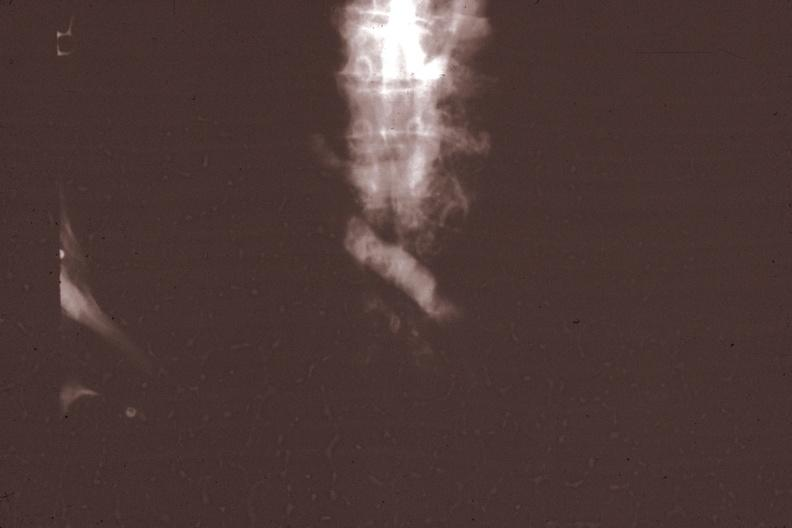what is present?
Answer the question using a single word or phrase. Malignant thymoma 